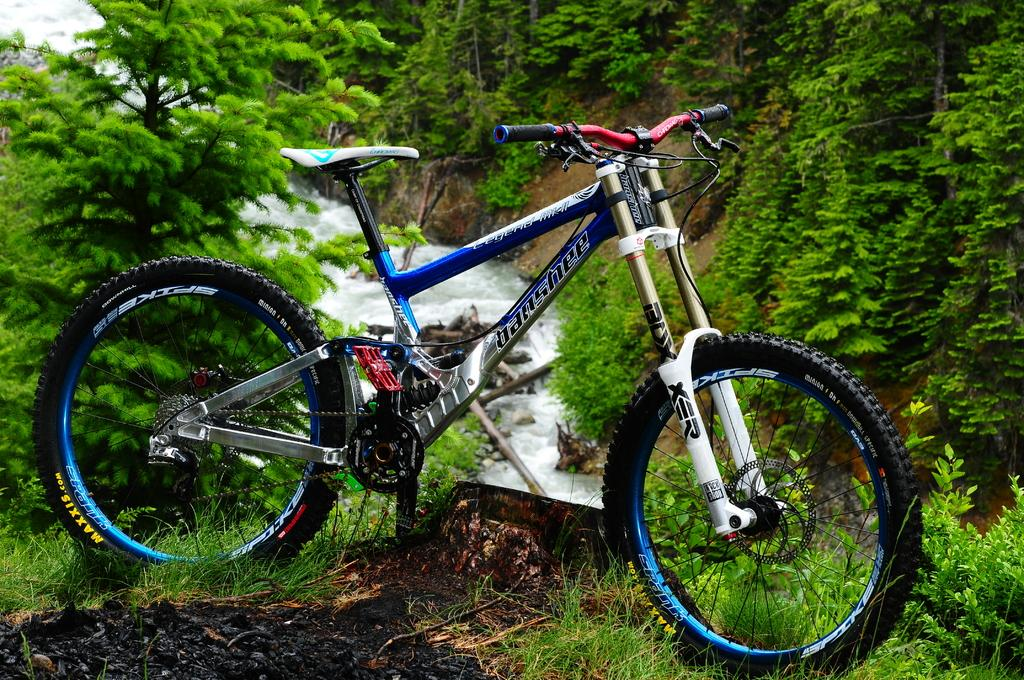Where was the picture taken? The picture was clicked outside. What can be seen in the foreground of the image? A bicycle is parked on the ground in the foreground. What type of vegetation is present in the image? There is green grass, plants, and trees visible in the image. What other natural elements can be seen in the image? Rocks and running water are present in the image. What type of rice is being cooked in the image? There is no rice present in the image; it features a bicycle parked outside with various natural elements. 